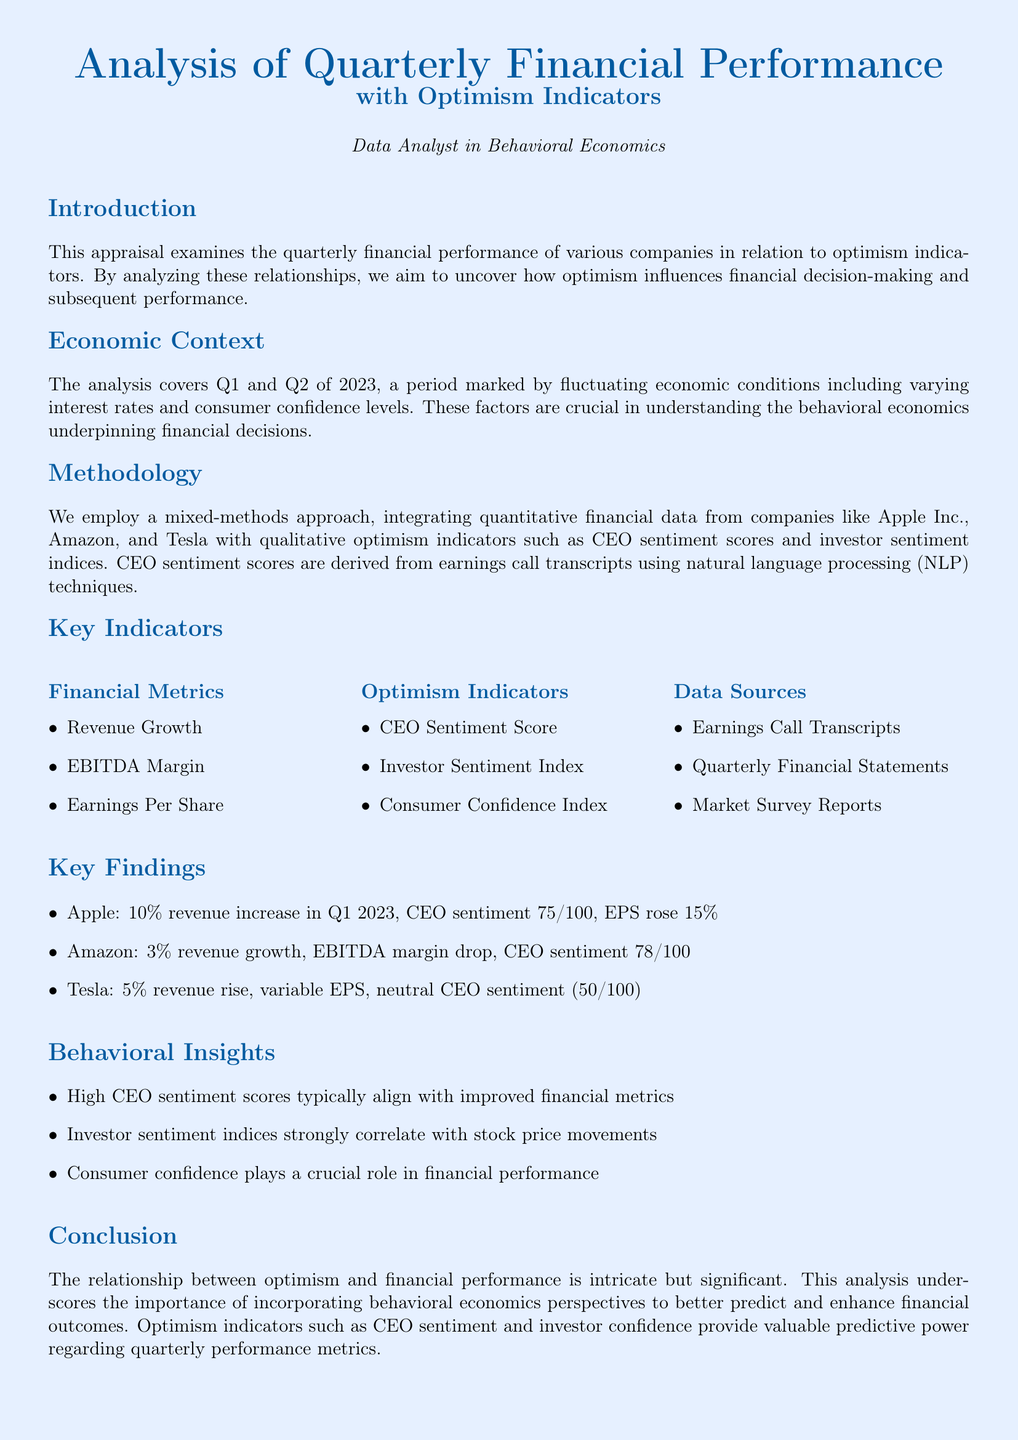What is the analysis period covered? The analysis focuses on two quarters, specifically Q1 and Q2 of 2023.
Answer: Q1 and Q2 of 2023 Who is one of the companies analyzed? The document mentions specific companies analyzed for their financial performance, including Apple Inc.
Answer: Apple Inc What was the CEO sentiment score for Amazon? The document states that Amazon's CEO sentiment score is indicative of its leadership's outlook and is listed in the findings.
Answer: 78/100 What was Tesla's revenue growth percentage? The analysis provides Tesla's financial performance metrics, including revenue changes.
Answer: 5% Which indicator strongly correlates with stock price movements? The document notes that certain sentiments closely link to stock performances, specifically related to investor sentiment.
Answer: Investor sentiment index What methodology is used in this appraisal? The document describes the methods employed, detailing the analysis approach taken.
Answer: Mixed-methods approach What is a key financial metric listed? The document includes several financial metrics which are crucial for the analysis of performance.
Answer: EBITDA Margin Which qualitative optimism indicator is derived from earnings call transcripts? The analysis highlights specific indicators that emerge from company communication, particularly focusing on the leadership's tone and outlook.
Answer: CEO Sentiment Score 